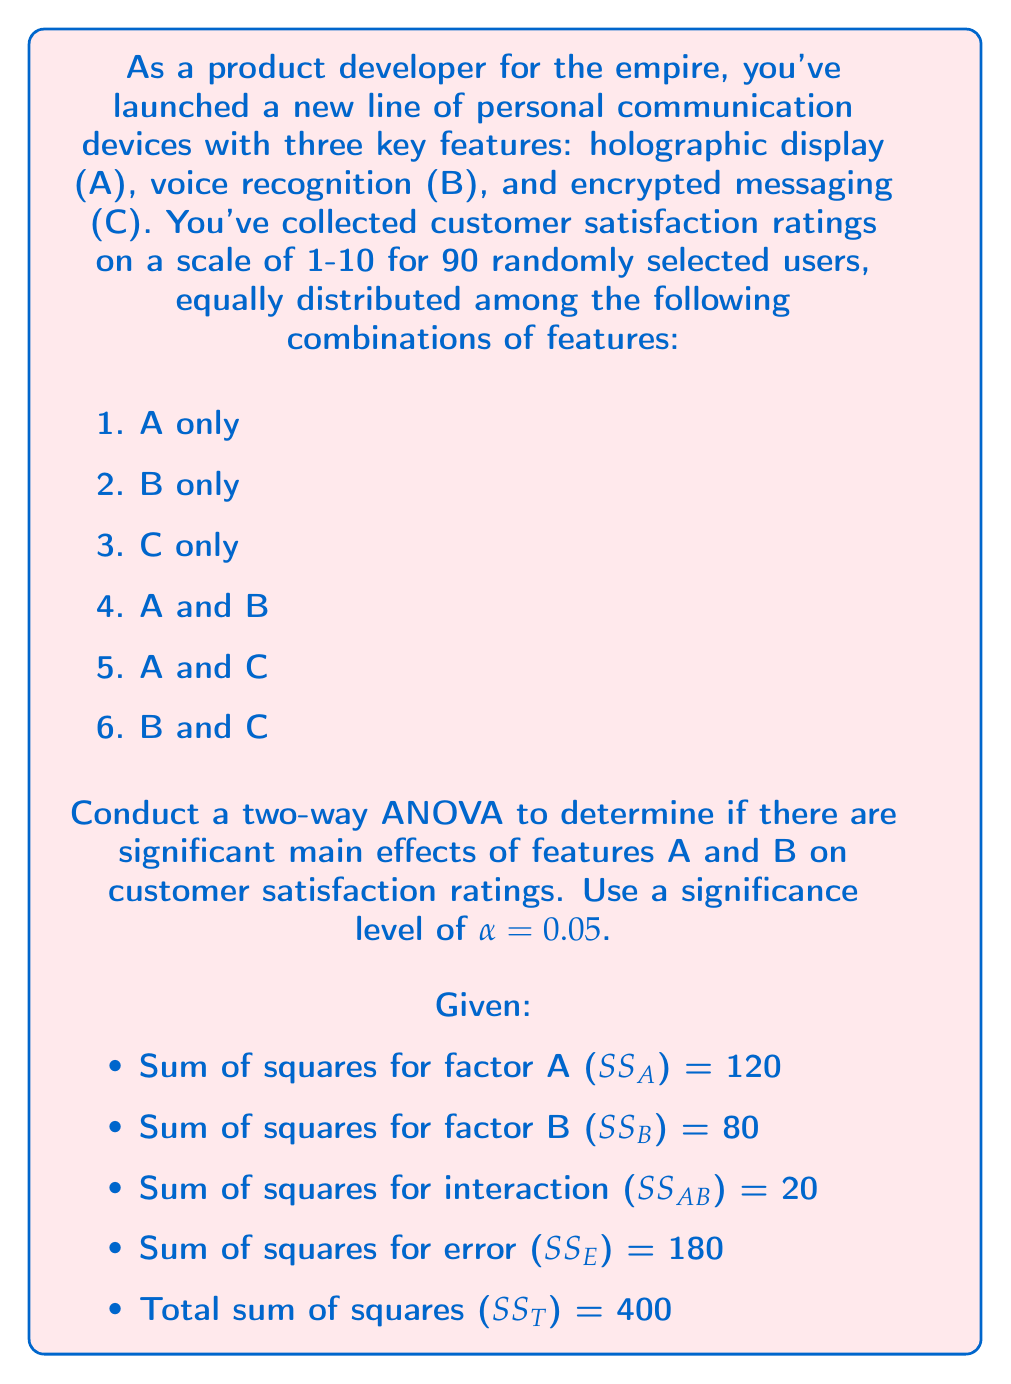Solve this math problem. To conduct a two-way ANOVA, we need to follow these steps:

1. Calculate degrees of freedom (df):
   - df_A = levels of A - 1 = 2 - 1 = 1
   - df_B = levels of B - 1 = 2 - 1 = 1
   - df_AB = df_A × df_B = 1 × 1 = 1
   - df_E = n - (levels of A × levels of B) = 90 - (2 × 2) = 86
   - df_T = n - 1 = 90 - 1 = 89

2. Calculate mean squares (MS):
   $$ MS_A = \frac{SS_A}{df_A} = \frac{120}{1} = 120 $$
   $$ MS_B = \frac{SS_B}{df_B} = \frac{80}{1} = 80 $$
   $$ MS_{AB} = \frac{SS_{AB}}{df_{AB}} = \frac{20}{1} = 20 $$
   $$ MS_E = \frac{SS_E}{df_E} = \frac{180}{86} \approx 2.093 $$

3. Calculate F-ratios:
   $$ F_A = \frac{MS_A}{MS_E} = \frac{120}{2.093} \approx 57.334 $$
   $$ F_B = \frac{MS_B}{MS_E} = \frac{80}{2.093} \approx 38.223 $$

4. Determine critical F-values:
   For α = 0.05, df_numerator = 1, df_denominator = 86
   F_critical ≈ 3.952 (from F-distribution table)

5. Compare F-ratios to F-critical:
   - For factor A: 57.334 > 3.952
   - For factor B: 38.223 > 3.952

6. Make decisions:
   - Reject H0 for factor A (holographic display) as F_A > F_critical
   - Reject H0 for factor B (voice recognition) as F_B > F_critical

7. Calculate effect sizes (partial eta-squared):
   $$ \eta^2_A = \frac{SS_A}{SS_A + SS_E} = \frac{120}{120 + 180} = 0.4 $$
   $$ \eta^2_B = \frac{SS_B}{SS_B + SS_E} = \frac{80}{80 + 180} \approx 0.308 $$
Answer: There are significant main effects of both holographic display (F(1, 86) ≈ 57.334, p < 0.05, η² = 0.4) and voice recognition (F(1, 86) ≈ 38.223, p < 0.05, η² ≈ 0.308) on customer satisfaction ratings. Both features have a large effect size, with holographic display having a slightly larger impact on customer satisfaction. 